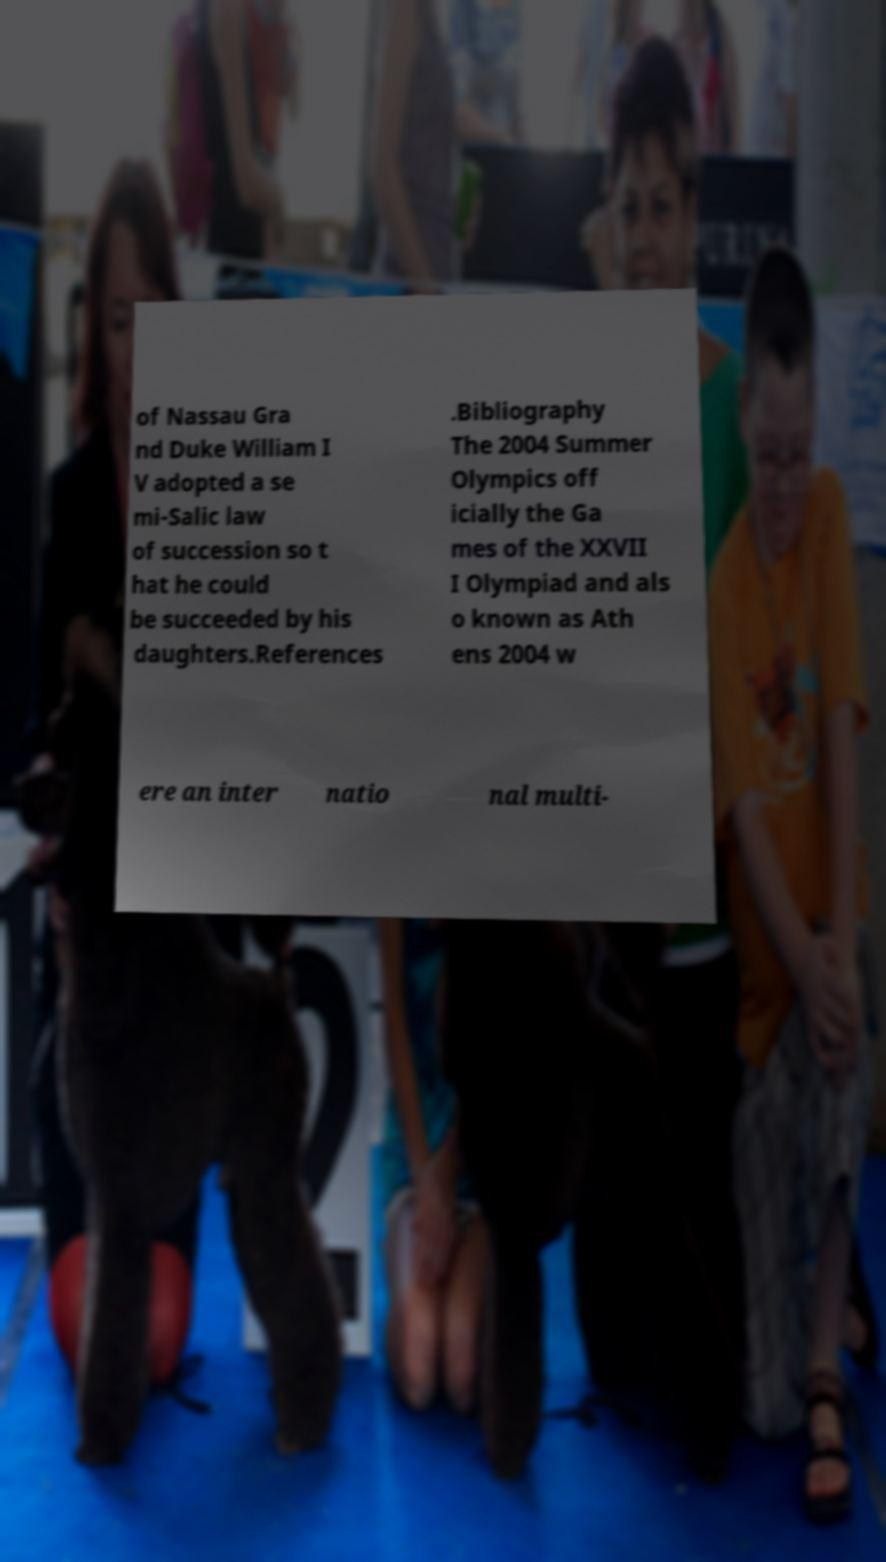Please read and relay the text visible in this image. What does it say? of Nassau Gra nd Duke William I V adopted a se mi-Salic law of succession so t hat he could be succeeded by his daughters.References .Bibliography The 2004 Summer Olympics off icially the Ga mes of the XXVII I Olympiad and als o known as Ath ens 2004 w ere an inter natio nal multi- 